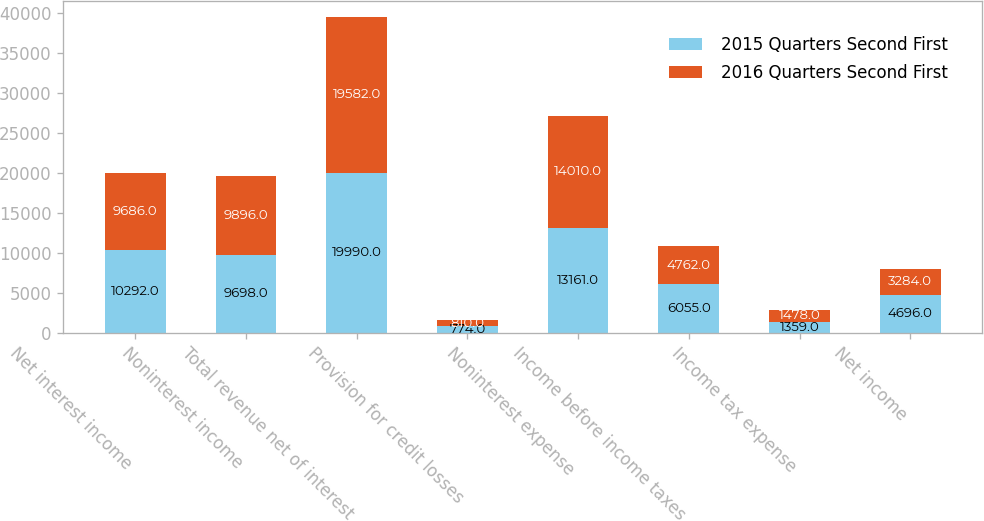Convert chart. <chart><loc_0><loc_0><loc_500><loc_500><stacked_bar_chart><ecel><fcel>Net interest income<fcel>Noninterest income<fcel>Total revenue net of interest<fcel>Provision for credit losses<fcel>Noninterest expense<fcel>Income before income taxes<fcel>Income tax expense<fcel>Net income<nl><fcel>2015 Quarters Second First<fcel>10292<fcel>9698<fcel>19990<fcel>774<fcel>13161<fcel>6055<fcel>1359<fcel>4696<nl><fcel>2016 Quarters Second First<fcel>9686<fcel>9896<fcel>19582<fcel>810<fcel>14010<fcel>4762<fcel>1478<fcel>3284<nl></chart> 